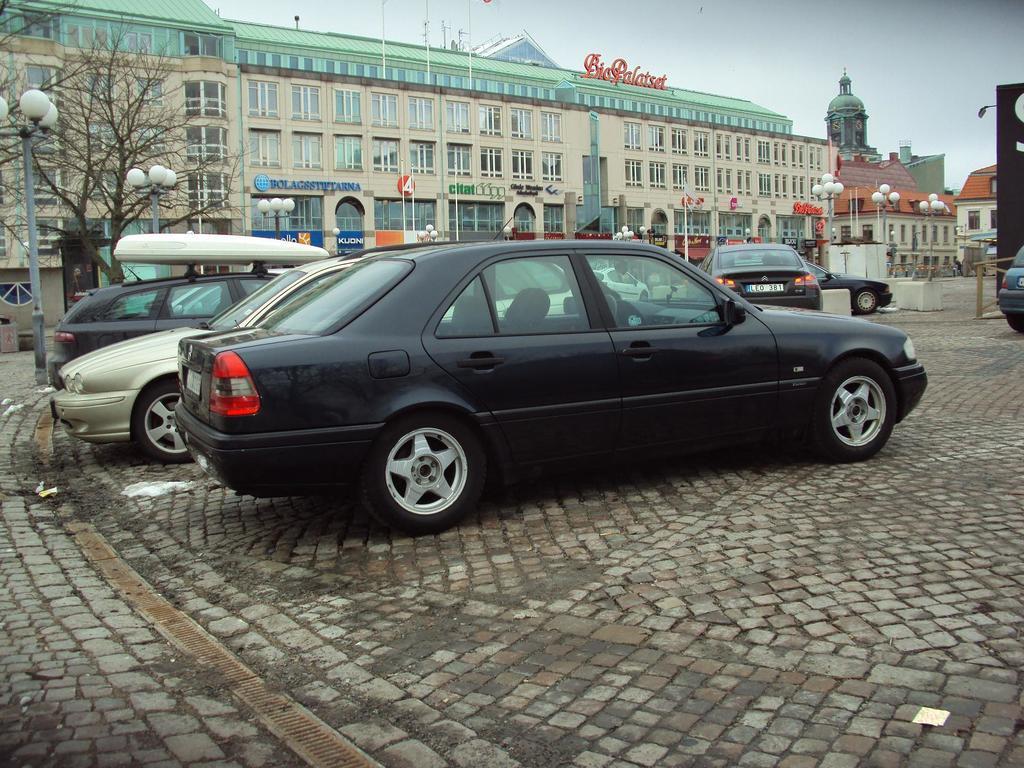Could you give a brief overview of what you see in this image? In the center of the image we can see cars on the road. In the background we can see buildings, trees, lights and sky. 